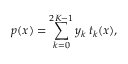<formula> <loc_0><loc_0><loc_500><loc_500>p ( x ) = \sum _ { k = 0 } ^ { 2 K - 1 } y _ { k } \, t _ { k } ( x ) ,</formula> 